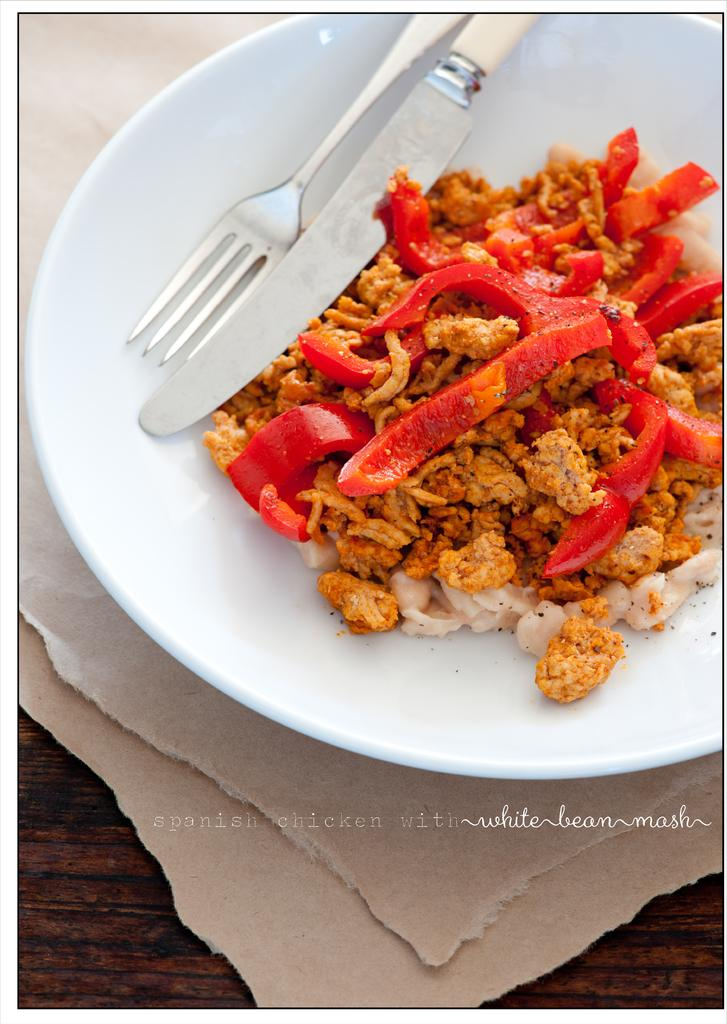What is on the plate in the image? There is food on the plate in the image. What utensils are present in the image? There is a fork and a knife in the image. What is the surface on which the plate and utensils are placed? The objects are on a wooden platform. What type of roof can be seen above the wooden platform in the image? There is no roof visible in the image; it only shows a plate with food, utensils, and a wooden platform. 